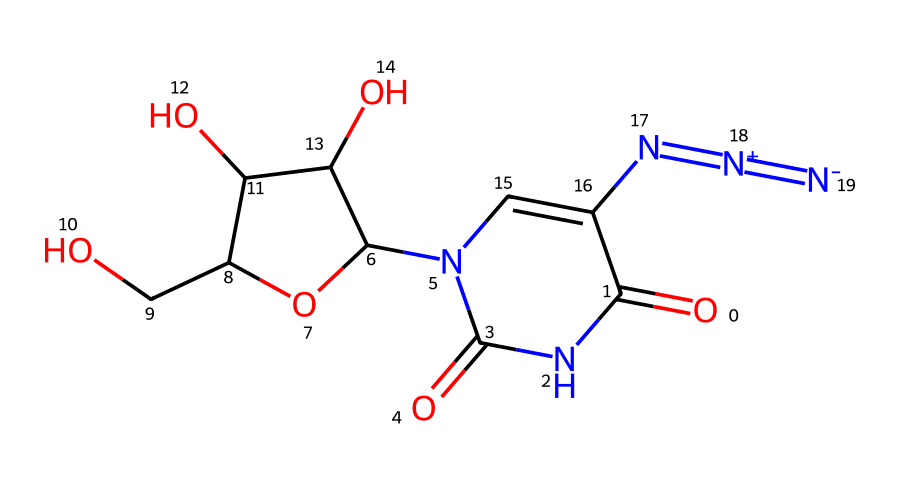What is the chemical name of the structure represented by the given SMILES? The SMILES notation corresponds to a molecule with a specific structure, which is identified as 5-azidouridine due to its structural components, including the azide group (-N3) and the uridine base.
Answer: 5-azidouridine How many nitrogen atoms are present in this chemical structure? By analyzing the SMILES representation, we can count the nitrogen atoms: there are three in the azide group and two in the purine-like structure, totaling five nitrogen atoms.
Answer: five What types of functional groups are present in this molecule? The molecule contains an azide functional group (-N3) and two carbonyl groups (C=O) as indicated by the positioning in the SMILES string, as well as hydroxyl (-OH) groups as part of the ribofuranosyl portion.
Answer: azide and carbonyl groups What is the number of rings present in the structure? Looking at the SMILES representation, we can identify that there is one cyclic structure associated with the ribofuranosyl part of the molecule, leading us to conclude that there is one ring present.
Answer: one How does the presence of azide potentially influence the biological activity of this compound? The azide group is known for its ability to act as an electrophile in biological pathways, which can enhance interactions with biomolecules; thus, its presence could contribute to the antiviral and antitumor properties of 5-azidouridine.
Answer: enhances interactions What is the sugar component of the molecule? The SMILES indicates a ribofuranose structure through its cyclic components and specific connectivity, confirming that the sugar present is ribose.
Answer: ribose Why is the nitrogen atom in the azide group specified with oxidation states? The SMILES notation specifies the nitrogen atoms in the azide group using oxidation state representations (+ and -), indicating their formal charge states, which are essential for understanding the reactivity and stability of the azide group.
Answer: reactivity and stability 